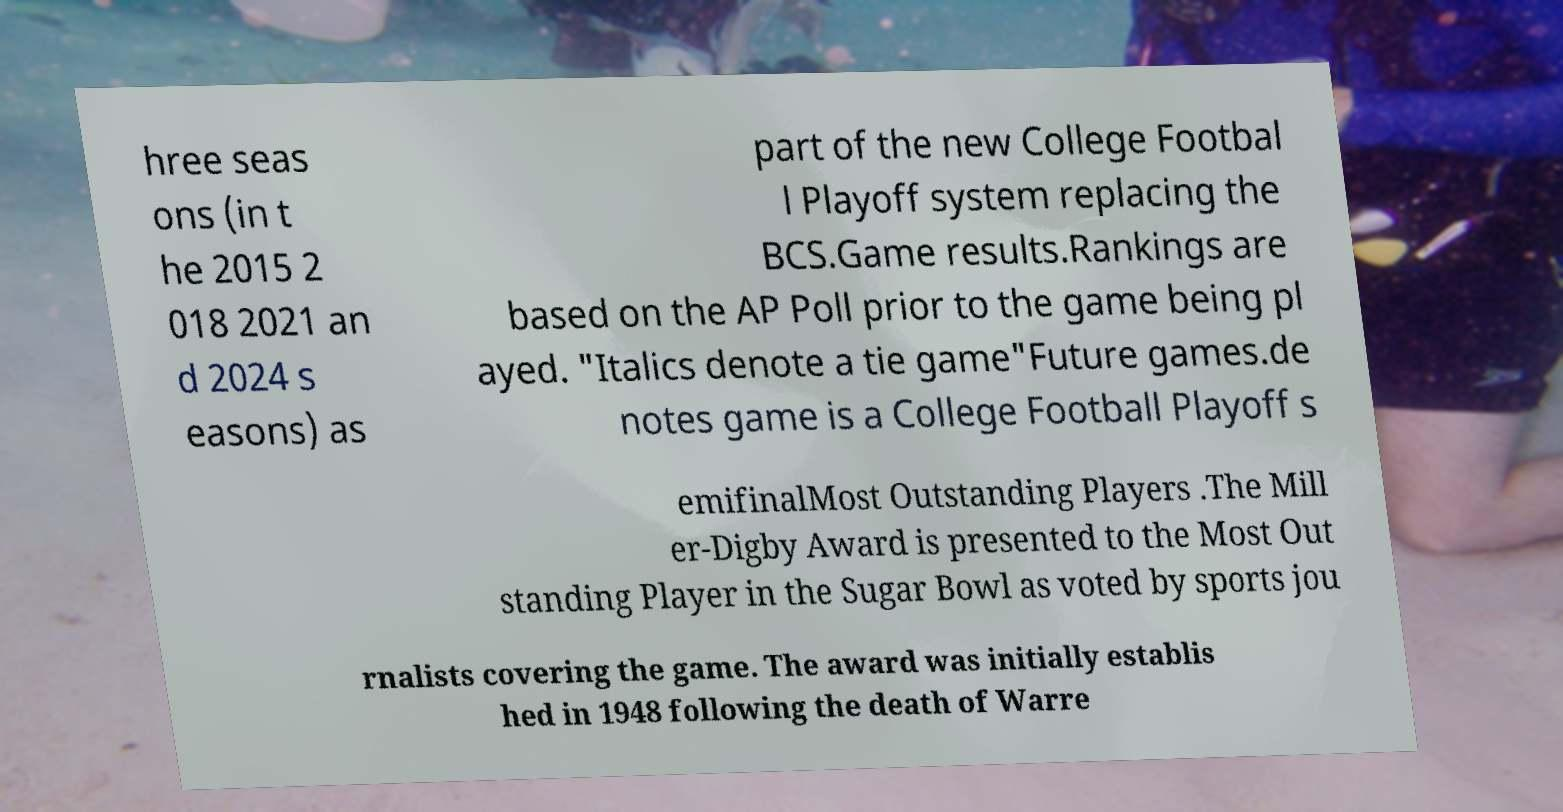For documentation purposes, I need the text within this image transcribed. Could you provide that? hree seas ons (in t he 2015 2 018 2021 an d 2024 s easons) as part of the new College Footbal l Playoff system replacing the BCS.Game results.Rankings are based on the AP Poll prior to the game being pl ayed. "Italics denote a tie game"Future games.de notes game is a College Football Playoff s emifinalMost Outstanding Players .The Mill er-Digby Award is presented to the Most Out standing Player in the Sugar Bowl as voted by sports jou rnalists covering the game. The award was initially establis hed in 1948 following the death of Warre 